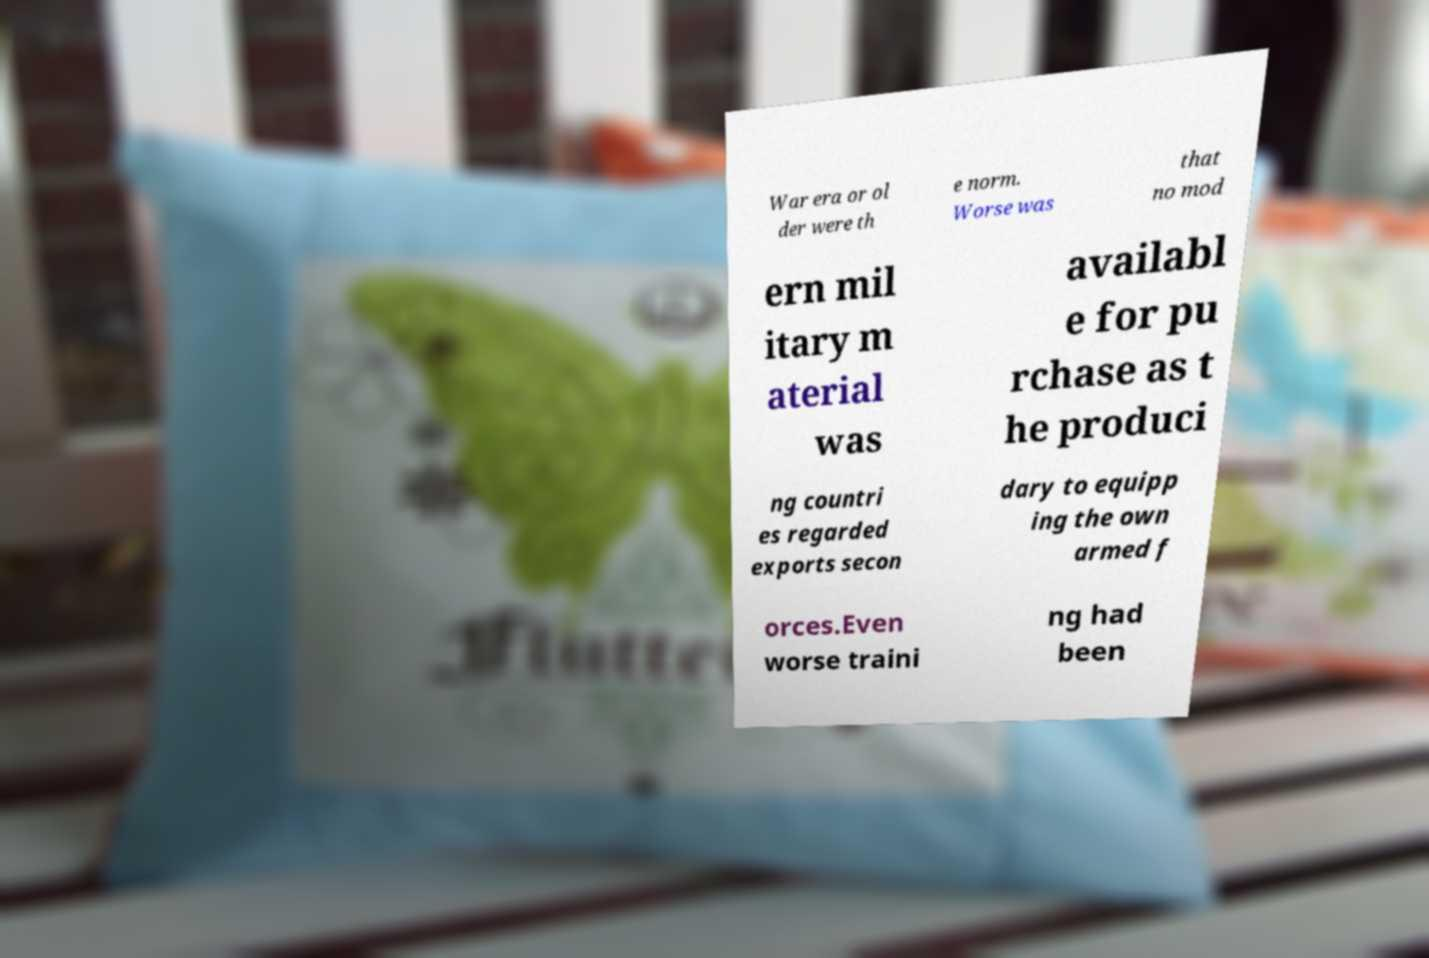For documentation purposes, I need the text within this image transcribed. Could you provide that? War era or ol der were th e norm. Worse was that no mod ern mil itary m aterial was availabl e for pu rchase as t he produci ng countri es regarded exports secon dary to equipp ing the own armed f orces.Even worse traini ng had been 